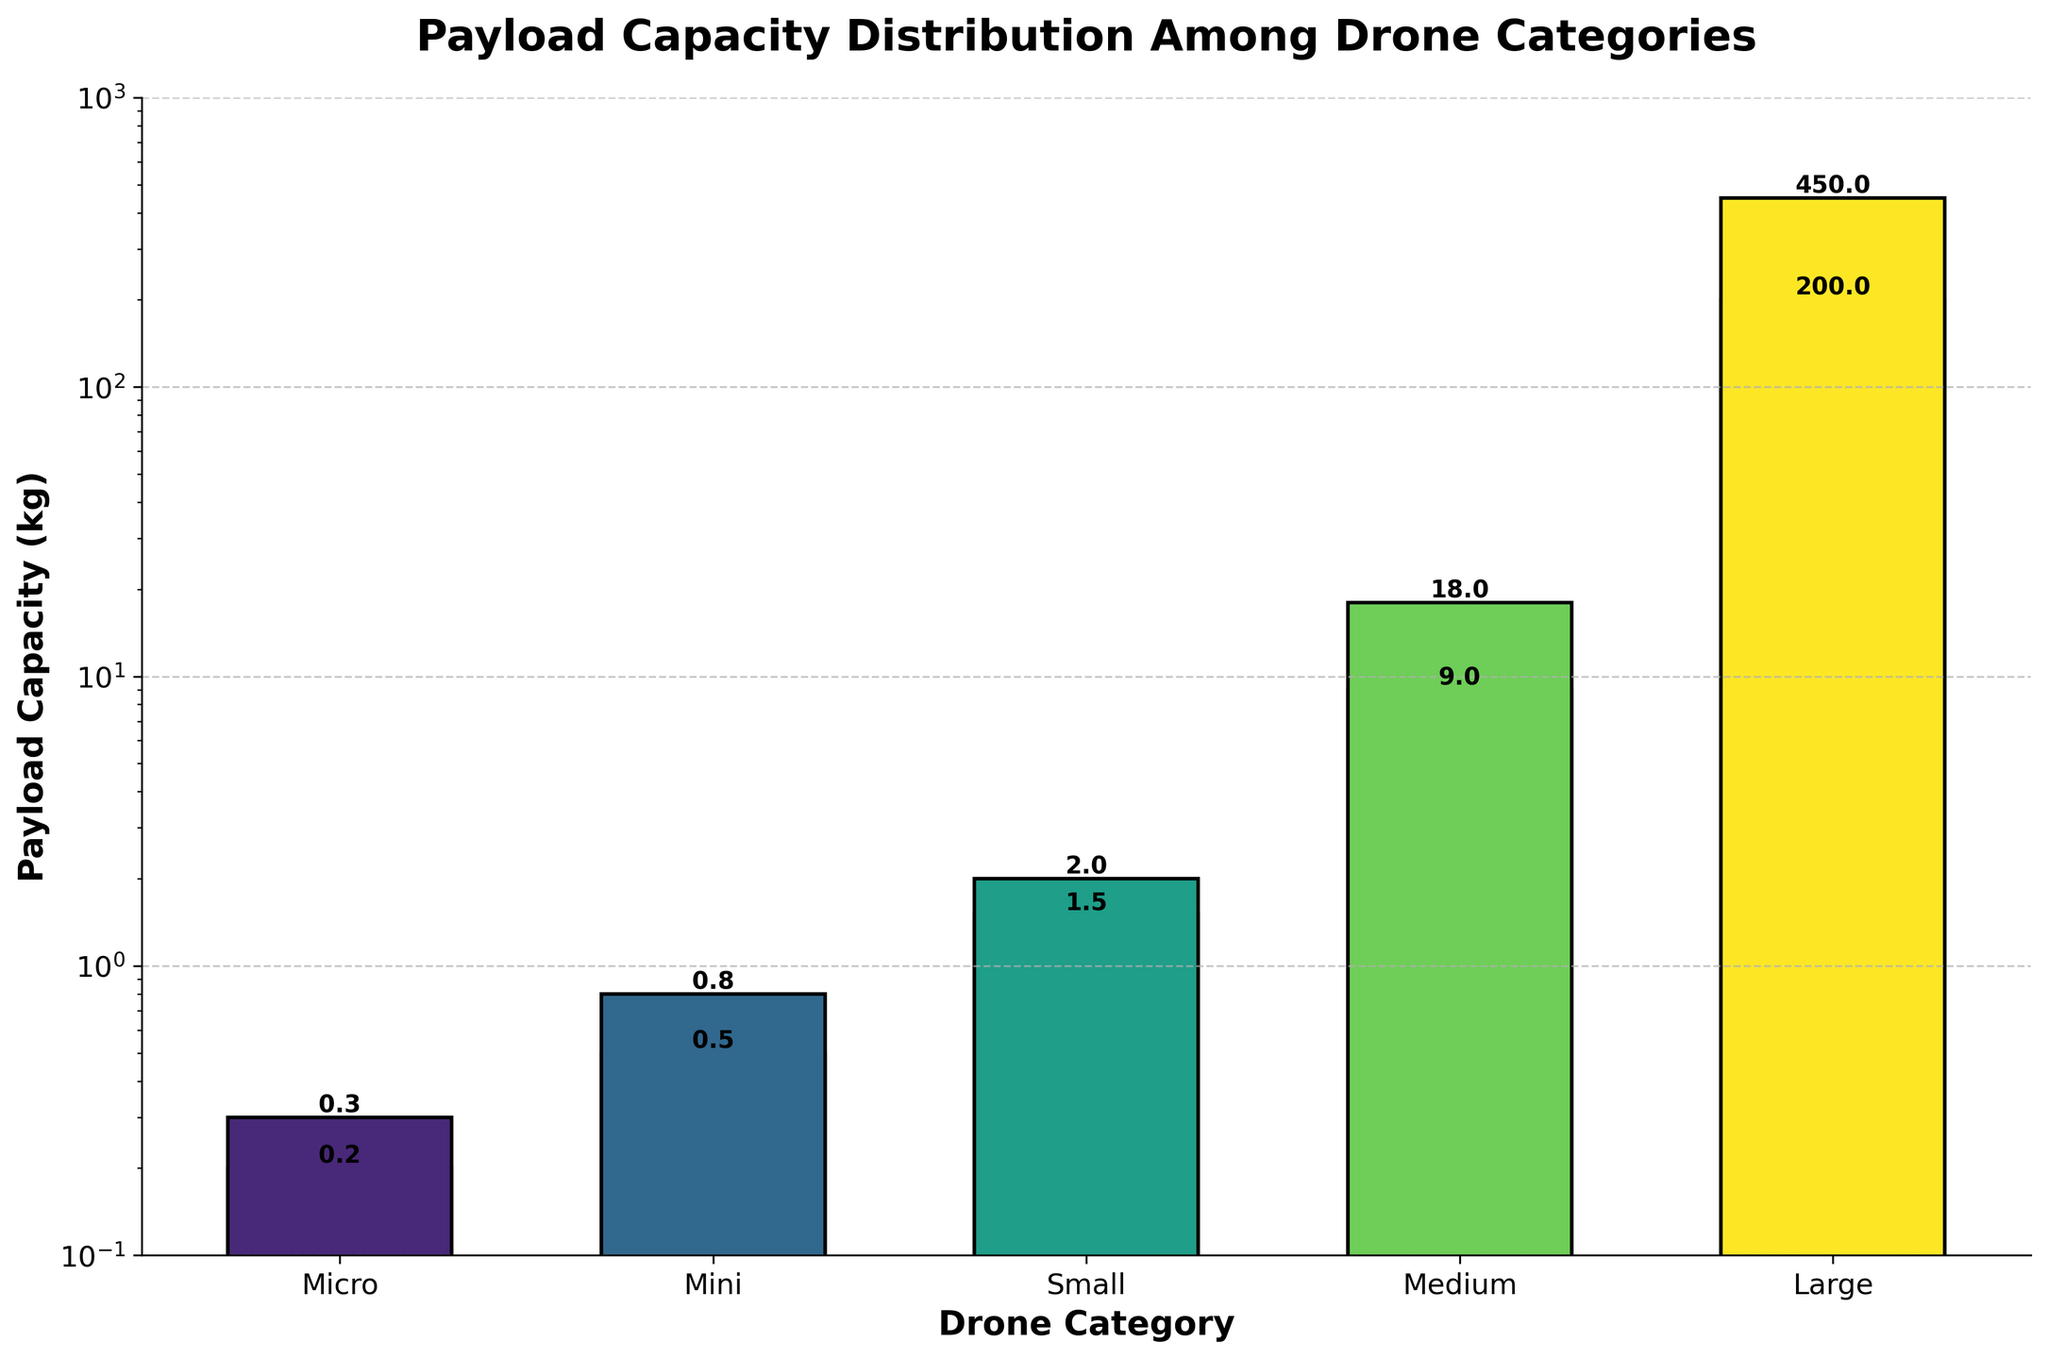What's the category with the highest payload capacity? The figure shows that the "Large" category has significantly higher payload capacities compared to other categories, with the highest being "Volocopter VoloDrone" at 450 kg.
Answer: Large What is the payload capacity range for the "Micro" category drones? In the figure, the "Micro" category drones (DJI Mavic Mini and Autel EVO Nano) have payload capacities of 0.2 kg and 0.3 kg, respectively. Therefore, the range is from 0.2 kg to 0.3 kg.
Answer: 0.2 kg to 0.3 kg What is the median payload capacity for the dataset? To get the median, we list the payload capacities in ascending order: [0.2, 0.3, 0.5, 0.8, 1.5, 2.0, 9.0, 18.0, 200.0, 450.0]. The median, or middle value, is the average of the 5th and 6th entries: (1.5 + 2.0)/2 = 1.75.
Answer: 1.75 kg How does the payload capacity of the "Small" category compare to the "Medium" category? The "Small" category drones have payload capacities of 1.5 kg and 2.0 kg, whereas the "Medium" category drones have capacities of 9.0 kg and 18.0 kg. Clearly, the "Medium" category has significantly higher payload capacities.
Answer: Medium is higher Which category has the lowest payload capacity, and what is it? The figure shows that the "Micro" category has the lowest payload capacity, with the DJI Mavic Mini having just 0.2 kg.
Answer: Micro, 0.2 kg What's the average payload capacity for the "Large" category? For the "Large" category, we average the payload capacities of Griff Aviation 300 (200 kg) and Volocopter VoloDrone (450 kg): (200 + 450)/2 = 325.
Answer: 325 kg Is there a significant difference between the payload capacities of "Medium" and "Large" categories? Yes, the "Medium" category has payloads of 9.0 kg and 18.0 kg, whereas the "Large" category has much higher payloads of 200 kg and 450 kg. The difference is substantial, especially when viewed on a logarithmic scale.
Answer: Yes Rank the drone categories from the highest to the lowest payload capacity. The figure allows us to rank the categories based on their highest payload capacities: Large (Volocopter VoloDrone 450 kg) > Medium (FreeFly Alta X 18 kg) > Small (Yuneec Typhoon H3 2 kg) > Mini (DJI Air 2S 0.8 kg) > Micro (Autel EVO Nano 0.3 kg).
Answer: Large > Medium > Small > Mini > Micro How many categories have a payload capacity of more than 10 kg? From the figure, only the "Medium" and "Large" categories have drones with payload capacities exceeding 10 kg.
Answer: 2 Compare the highest payload capacity in the "Mini" category with the lowest in the "Large" category. The highest payload capacity in the "Mini" category is 0.8 kg, while the lowest in the "Large" category is 200 kg. Therefore, the lowest payload in the "Large" category far exceeds the highest in the "Mini" category.
Answer: Large (200 kg) is higher 